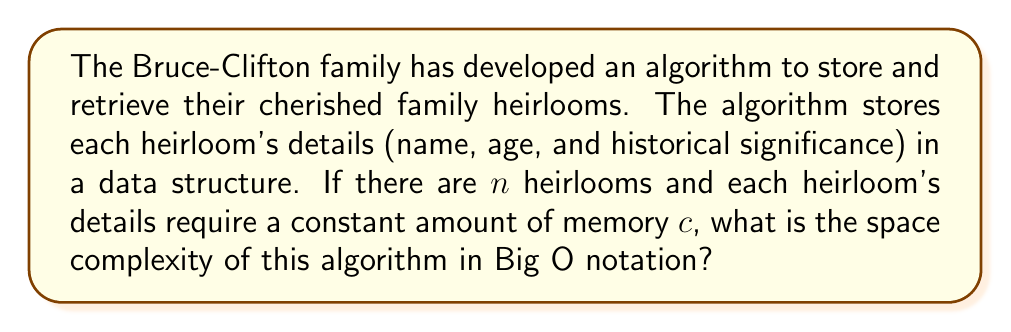Help me with this question. To determine the space complexity of this algorithm, we need to analyze how the memory usage grows with respect to the input size. In this case, the input size is the number of heirlooms, $n$.

Step 1: Analyze the memory usage for each heirloom
- Each heirloom requires a constant amount of memory $c$ to store its details (name, age, and historical significance).

Step 2: Calculate the total memory usage
- For $n$ heirlooms, the total memory usage will be $n \times c$.

Step 3: Express the space complexity in Big O notation
- The space complexity is a linear function of $n$: $f(n) = cn$
- In Big O notation, we drop constant factors and focus on the growth rate.
- Therefore, the space complexity is $O(n)$.

This means that the memory usage of the algorithm grows linearly with the number of heirlooms. As the Bruce-Clifton family adds more heirlooms to their collection, the memory required to store and retrieve their information will increase proportionally.
Answer: $O(n)$ 